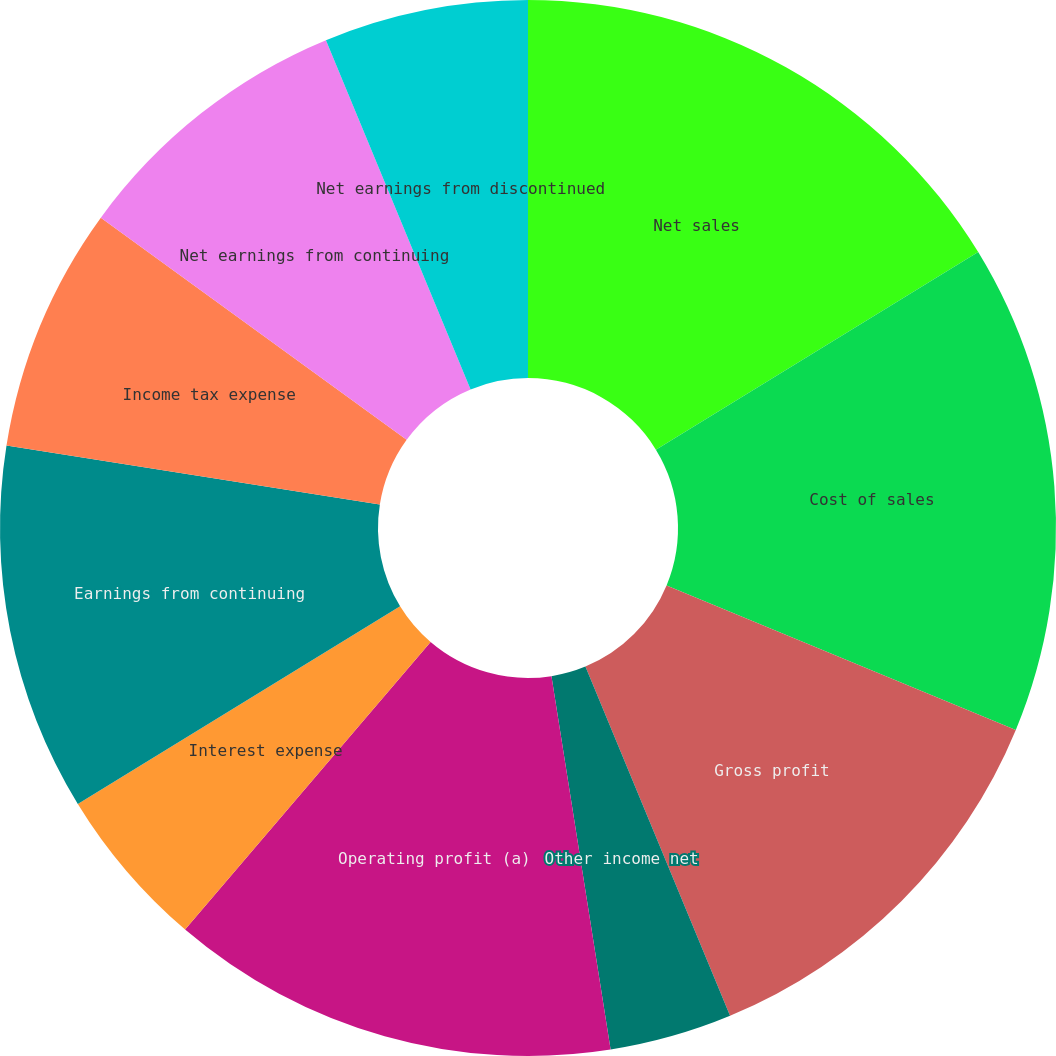<chart> <loc_0><loc_0><loc_500><loc_500><pie_chart><fcel>Net sales<fcel>Cost of sales<fcel>Gross profit<fcel>Other income net<fcel>Operating profit (a)<fcel>Interest expense<fcel>Earnings from continuing<fcel>Income tax expense<fcel>Net earnings from continuing<fcel>Net earnings from discontinued<nl><fcel>16.25%<fcel>15.0%<fcel>12.5%<fcel>3.75%<fcel>13.75%<fcel>5.0%<fcel>11.25%<fcel>7.5%<fcel>8.75%<fcel>6.25%<nl></chart> 